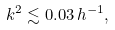<formula> <loc_0><loc_0><loc_500><loc_500>k ^ { 2 } \lesssim 0 . 0 3 \, h ^ { - 1 } ,</formula> 